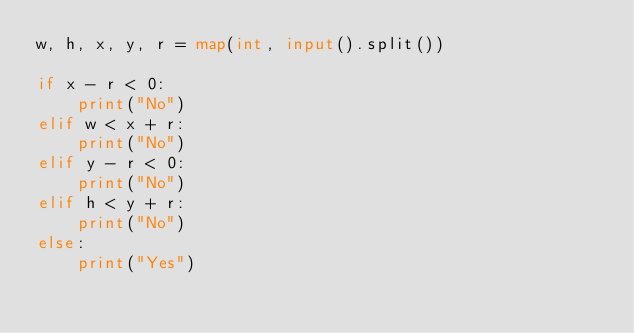Convert code to text. <code><loc_0><loc_0><loc_500><loc_500><_Python_>w, h, x, y, r = map(int, input().split())

if x - r < 0:
    print("No")
elif w < x + r:
    print("No")
elif y - r < 0:
    print("No")
elif h < y + r:
    print("No")
else:
    print("Yes")</code> 